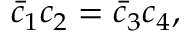Convert formula to latex. <formula><loc_0><loc_0><loc_500><loc_500>\bar { c } _ { 1 } c _ { 2 } = \bar { c } _ { 3 } c _ { 4 } ,</formula> 